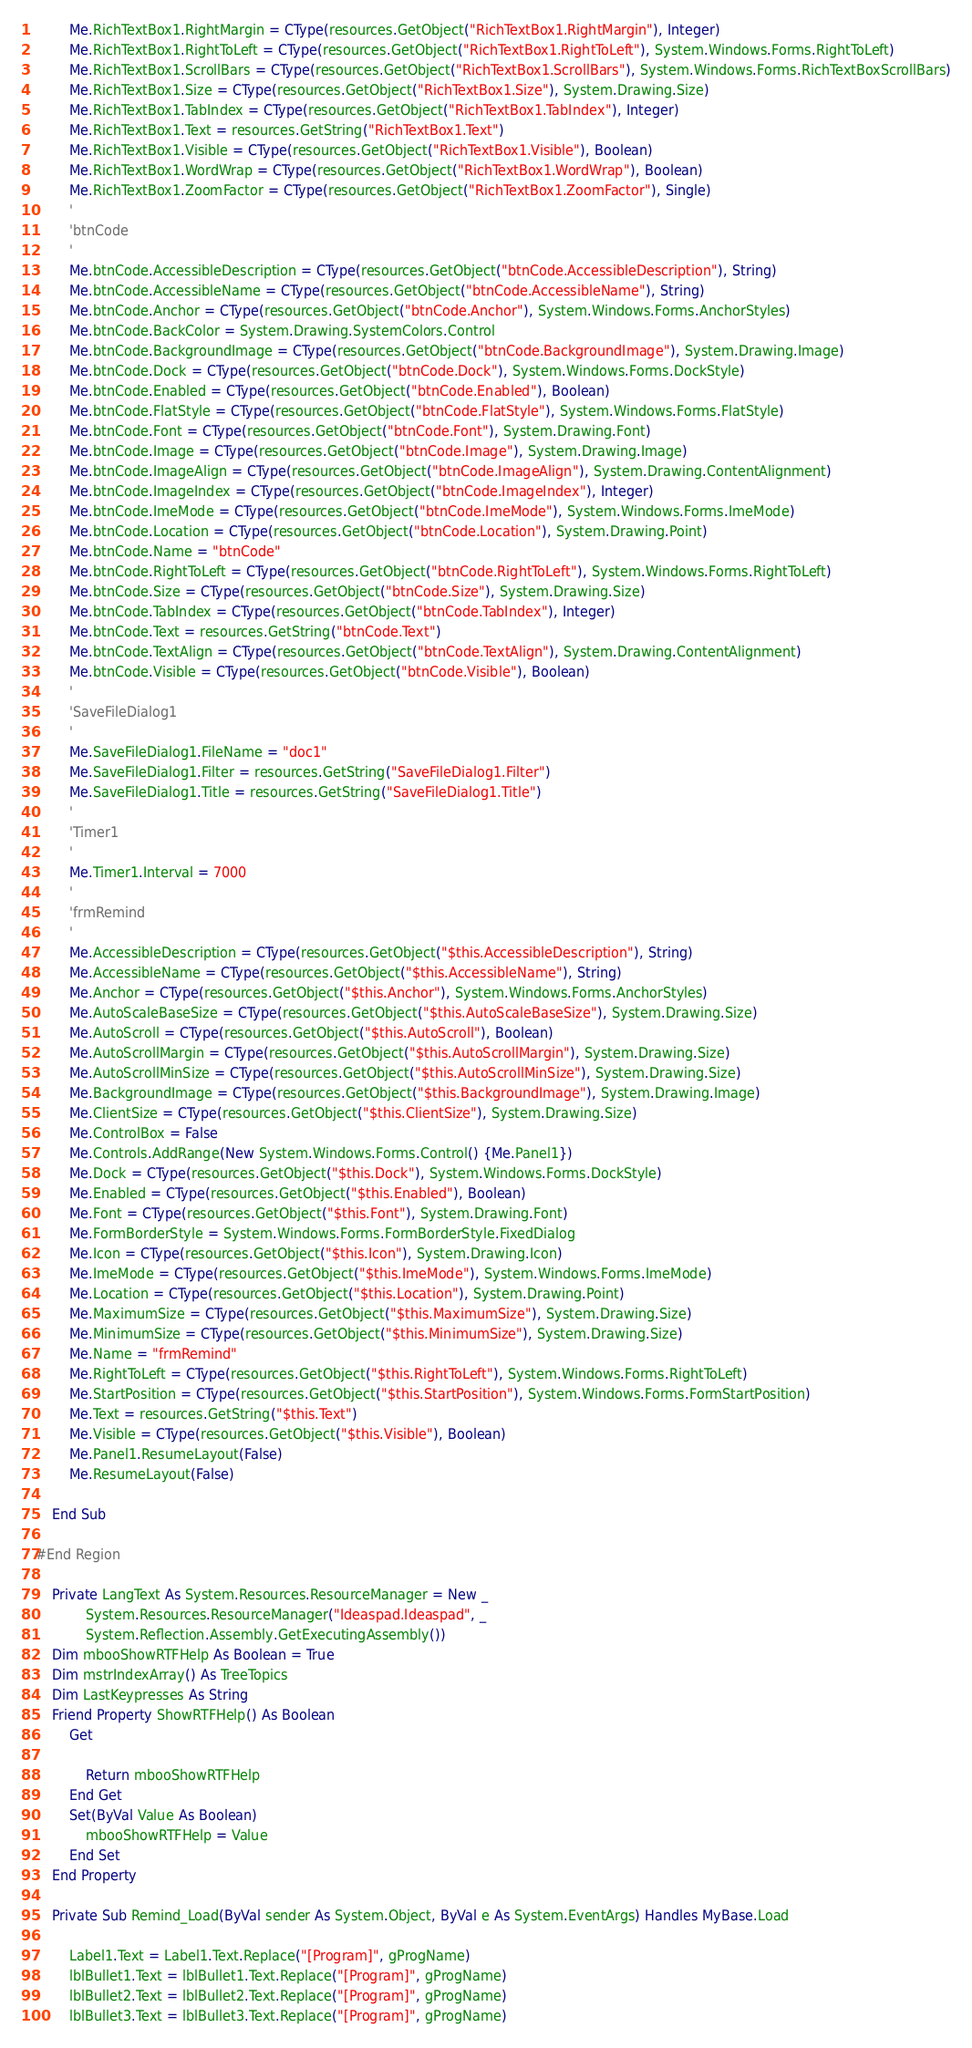<code> <loc_0><loc_0><loc_500><loc_500><_VisualBasic_>        Me.RichTextBox1.RightMargin = CType(resources.GetObject("RichTextBox1.RightMargin"), Integer)
        Me.RichTextBox1.RightToLeft = CType(resources.GetObject("RichTextBox1.RightToLeft"), System.Windows.Forms.RightToLeft)
        Me.RichTextBox1.ScrollBars = CType(resources.GetObject("RichTextBox1.ScrollBars"), System.Windows.Forms.RichTextBoxScrollBars)
        Me.RichTextBox1.Size = CType(resources.GetObject("RichTextBox1.Size"), System.Drawing.Size)
        Me.RichTextBox1.TabIndex = CType(resources.GetObject("RichTextBox1.TabIndex"), Integer)
        Me.RichTextBox1.Text = resources.GetString("RichTextBox1.Text")
        Me.RichTextBox1.Visible = CType(resources.GetObject("RichTextBox1.Visible"), Boolean)
        Me.RichTextBox1.WordWrap = CType(resources.GetObject("RichTextBox1.WordWrap"), Boolean)
        Me.RichTextBox1.ZoomFactor = CType(resources.GetObject("RichTextBox1.ZoomFactor"), Single)
        '
        'btnCode
        '
        Me.btnCode.AccessibleDescription = CType(resources.GetObject("btnCode.AccessibleDescription"), String)
        Me.btnCode.AccessibleName = CType(resources.GetObject("btnCode.AccessibleName"), String)
        Me.btnCode.Anchor = CType(resources.GetObject("btnCode.Anchor"), System.Windows.Forms.AnchorStyles)
        Me.btnCode.BackColor = System.Drawing.SystemColors.Control
        Me.btnCode.BackgroundImage = CType(resources.GetObject("btnCode.BackgroundImage"), System.Drawing.Image)
        Me.btnCode.Dock = CType(resources.GetObject("btnCode.Dock"), System.Windows.Forms.DockStyle)
        Me.btnCode.Enabled = CType(resources.GetObject("btnCode.Enabled"), Boolean)
        Me.btnCode.FlatStyle = CType(resources.GetObject("btnCode.FlatStyle"), System.Windows.Forms.FlatStyle)
        Me.btnCode.Font = CType(resources.GetObject("btnCode.Font"), System.Drawing.Font)
        Me.btnCode.Image = CType(resources.GetObject("btnCode.Image"), System.Drawing.Image)
        Me.btnCode.ImageAlign = CType(resources.GetObject("btnCode.ImageAlign"), System.Drawing.ContentAlignment)
        Me.btnCode.ImageIndex = CType(resources.GetObject("btnCode.ImageIndex"), Integer)
        Me.btnCode.ImeMode = CType(resources.GetObject("btnCode.ImeMode"), System.Windows.Forms.ImeMode)
        Me.btnCode.Location = CType(resources.GetObject("btnCode.Location"), System.Drawing.Point)
        Me.btnCode.Name = "btnCode"
        Me.btnCode.RightToLeft = CType(resources.GetObject("btnCode.RightToLeft"), System.Windows.Forms.RightToLeft)
        Me.btnCode.Size = CType(resources.GetObject("btnCode.Size"), System.Drawing.Size)
        Me.btnCode.TabIndex = CType(resources.GetObject("btnCode.TabIndex"), Integer)
        Me.btnCode.Text = resources.GetString("btnCode.Text")
        Me.btnCode.TextAlign = CType(resources.GetObject("btnCode.TextAlign"), System.Drawing.ContentAlignment)
        Me.btnCode.Visible = CType(resources.GetObject("btnCode.Visible"), Boolean)
        '
        'SaveFileDialog1
        '
        Me.SaveFileDialog1.FileName = "doc1"
        Me.SaveFileDialog1.Filter = resources.GetString("SaveFileDialog1.Filter")
        Me.SaveFileDialog1.Title = resources.GetString("SaveFileDialog1.Title")
        '
        'Timer1
        '
        Me.Timer1.Interval = 7000
        '
        'frmRemind
        '
        Me.AccessibleDescription = CType(resources.GetObject("$this.AccessibleDescription"), String)
        Me.AccessibleName = CType(resources.GetObject("$this.AccessibleName"), String)
        Me.Anchor = CType(resources.GetObject("$this.Anchor"), System.Windows.Forms.AnchorStyles)
        Me.AutoScaleBaseSize = CType(resources.GetObject("$this.AutoScaleBaseSize"), System.Drawing.Size)
        Me.AutoScroll = CType(resources.GetObject("$this.AutoScroll"), Boolean)
        Me.AutoScrollMargin = CType(resources.GetObject("$this.AutoScrollMargin"), System.Drawing.Size)
        Me.AutoScrollMinSize = CType(resources.GetObject("$this.AutoScrollMinSize"), System.Drawing.Size)
        Me.BackgroundImage = CType(resources.GetObject("$this.BackgroundImage"), System.Drawing.Image)
        Me.ClientSize = CType(resources.GetObject("$this.ClientSize"), System.Drawing.Size)
        Me.ControlBox = False
        Me.Controls.AddRange(New System.Windows.Forms.Control() {Me.Panel1})
        Me.Dock = CType(resources.GetObject("$this.Dock"), System.Windows.Forms.DockStyle)
        Me.Enabled = CType(resources.GetObject("$this.Enabled"), Boolean)
        Me.Font = CType(resources.GetObject("$this.Font"), System.Drawing.Font)
        Me.FormBorderStyle = System.Windows.Forms.FormBorderStyle.FixedDialog
        Me.Icon = CType(resources.GetObject("$this.Icon"), System.Drawing.Icon)
        Me.ImeMode = CType(resources.GetObject("$this.ImeMode"), System.Windows.Forms.ImeMode)
        Me.Location = CType(resources.GetObject("$this.Location"), System.Drawing.Point)
        Me.MaximumSize = CType(resources.GetObject("$this.MaximumSize"), System.Drawing.Size)
        Me.MinimumSize = CType(resources.GetObject("$this.MinimumSize"), System.Drawing.Size)
        Me.Name = "frmRemind"
        Me.RightToLeft = CType(resources.GetObject("$this.RightToLeft"), System.Windows.Forms.RightToLeft)
        Me.StartPosition = CType(resources.GetObject("$this.StartPosition"), System.Windows.Forms.FormStartPosition)
        Me.Text = resources.GetString("$this.Text")
        Me.Visible = CType(resources.GetObject("$this.Visible"), Boolean)
        Me.Panel1.ResumeLayout(False)
        Me.ResumeLayout(False)

    End Sub

#End Region

    Private LangText As System.Resources.ResourceManager = New _
            System.Resources.ResourceManager("Ideaspad.Ideaspad", _
            System.Reflection.Assembly.GetExecutingAssembly()) 
    Dim mbooShowRTFHelp As Boolean = True
    Dim mstrIndexArray() As TreeTopics
    Dim LastKeypresses As String 
    Friend Property ShowRTFHelp() As Boolean
        Get

            Return mbooShowRTFHelp
        End Get
        Set(ByVal Value As Boolean)
            mbooShowRTFHelp = Value
        End Set
    End Property

    Private Sub Remind_Load(ByVal sender As System.Object, ByVal e As System.EventArgs) Handles MyBase.Load

        Label1.Text = Label1.Text.Replace("[Program]", gProgName) 
        lblBullet1.Text = lblBullet1.Text.Replace("[Program]", gProgName) 
        lblBullet2.Text = lblBullet2.Text.Replace("[Program]", gProgName) 
        lblBullet3.Text = lblBullet3.Text.Replace("[Program]", gProgName) </code> 